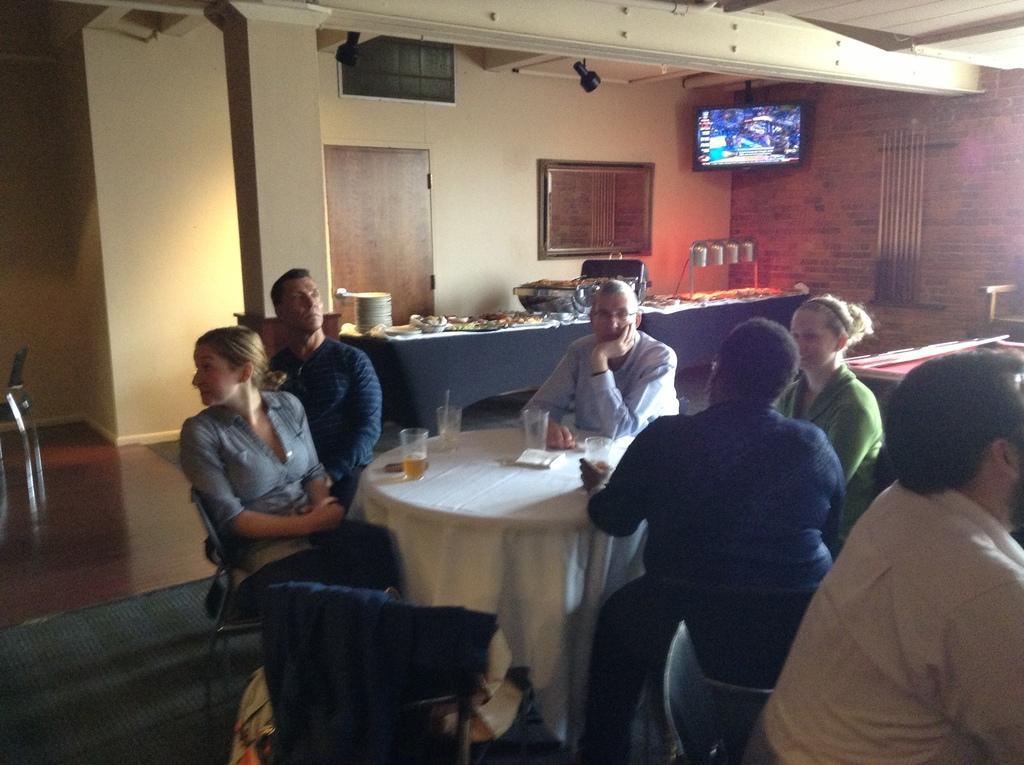Please provide a concise description of this image. There are few people sitting on chairs. In the middle on the table there are glasses, tissue. there are plates, food on a table here. Here is a screen mounted over here. Here there is a window and a door. 